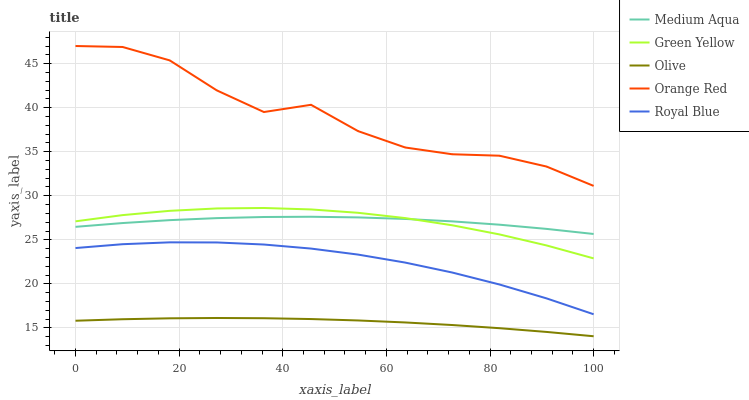Does Olive have the minimum area under the curve?
Answer yes or no. Yes. Does Orange Red have the maximum area under the curve?
Answer yes or no. Yes. Does Royal Blue have the minimum area under the curve?
Answer yes or no. No. Does Royal Blue have the maximum area under the curve?
Answer yes or no. No. Is Olive the smoothest?
Answer yes or no. Yes. Is Orange Red the roughest?
Answer yes or no. Yes. Is Royal Blue the smoothest?
Answer yes or no. No. Is Royal Blue the roughest?
Answer yes or no. No. Does Olive have the lowest value?
Answer yes or no. Yes. Does Royal Blue have the lowest value?
Answer yes or no. No. Does Orange Red have the highest value?
Answer yes or no. Yes. Does Royal Blue have the highest value?
Answer yes or no. No. Is Olive less than Royal Blue?
Answer yes or no. Yes. Is Orange Red greater than Royal Blue?
Answer yes or no. Yes. Does Medium Aqua intersect Green Yellow?
Answer yes or no. Yes. Is Medium Aqua less than Green Yellow?
Answer yes or no. No. Is Medium Aqua greater than Green Yellow?
Answer yes or no. No. Does Olive intersect Royal Blue?
Answer yes or no. No. 